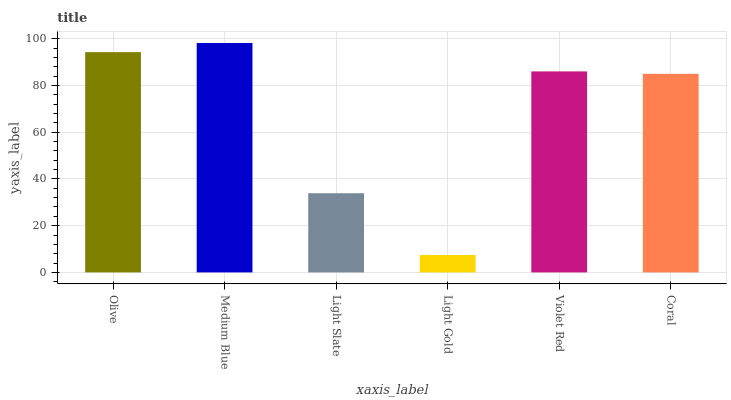Is Light Gold the minimum?
Answer yes or no. Yes. Is Medium Blue the maximum?
Answer yes or no. Yes. Is Light Slate the minimum?
Answer yes or no. No. Is Light Slate the maximum?
Answer yes or no. No. Is Medium Blue greater than Light Slate?
Answer yes or no. Yes. Is Light Slate less than Medium Blue?
Answer yes or no. Yes. Is Light Slate greater than Medium Blue?
Answer yes or no. No. Is Medium Blue less than Light Slate?
Answer yes or no. No. Is Violet Red the high median?
Answer yes or no. Yes. Is Coral the low median?
Answer yes or no. Yes. Is Light Slate the high median?
Answer yes or no. No. Is Violet Red the low median?
Answer yes or no. No. 